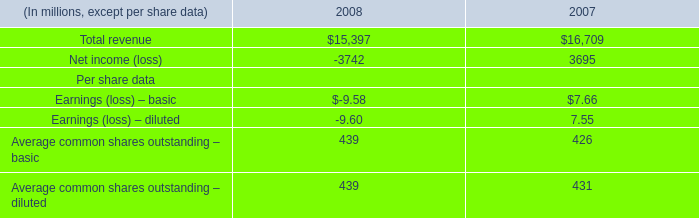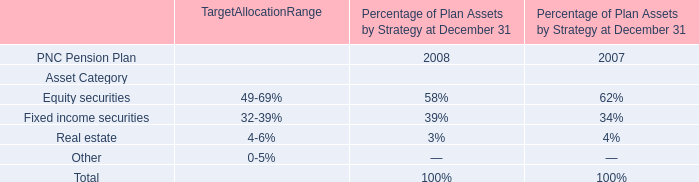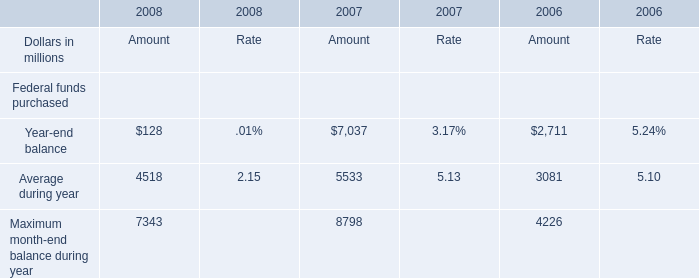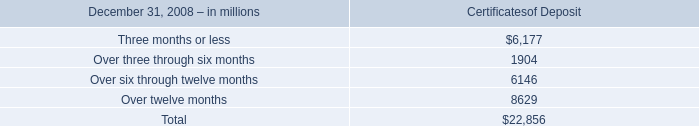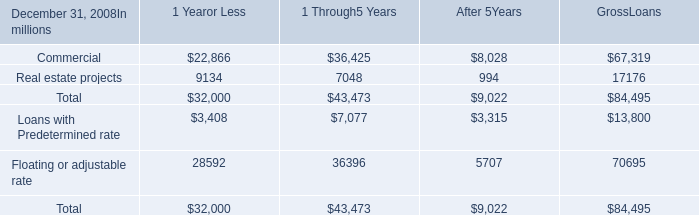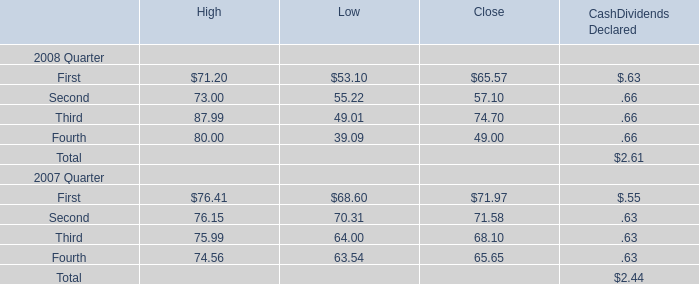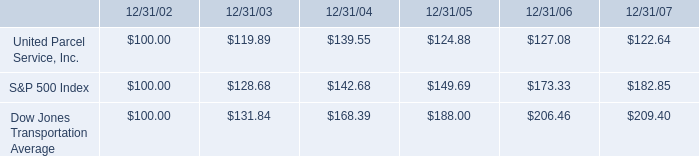What will Average during year be like in 2009 if it develops with the same increasing rate as current? (in million) 
Computations: (4518 * (1 + ((4518 - 5533) / 5533)))
Answer: 3689.19646. 